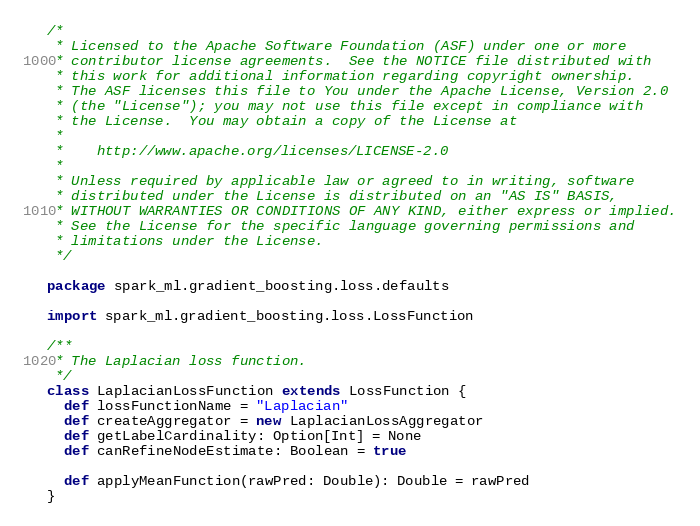Convert code to text. <code><loc_0><loc_0><loc_500><loc_500><_Scala_>/*
 * Licensed to the Apache Software Foundation (ASF) under one or more
 * contributor license agreements.  See the NOTICE file distributed with
 * this work for additional information regarding copyright ownership.
 * The ASF licenses this file to You under the Apache License, Version 2.0
 * (the "License"); you may not use this file except in compliance with
 * the License.  You may obtain a copy of the License at
 *
 *    http://www.apache.org/licenses/LICENSE-2.0
 *
 * Unless required by applicable law or agreed to in writing, software
 * distributed under the License is distributed on an "AS IS" BASIS,
 * WITHOUT WARRANTIES OR CONDITIONS OF ANY KIND, either express or implied.
 * See the License for the specific language governing permissions and
 * limitations under the License.
 */

package spark_ml.gradient_boosting.loss.defaults

import spark_ml.gradient_boosting.loss.LossFunction

/**
 * The Laplacian loss function.
 */
class LaplacianLossFunction extends LossFunction {
  def lossFunctionName = "Laplacian"
  def createAggregator = new LaplacianLossAggregator
  def getLabelCardinality: Option[Int] = None
  def canRefineNodeEstimate: Boolean = true

  def applyMeanFunction(rawPred: Double): Double = rawPred
}
</code> 